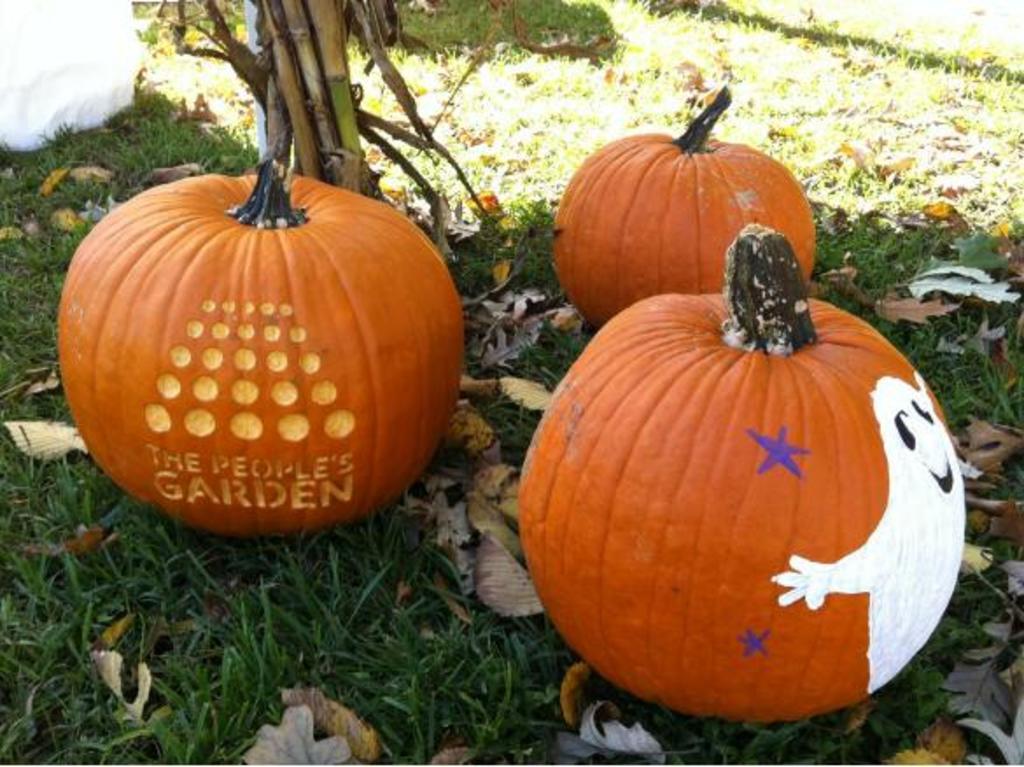Describe this image in one or two sentences. There are pumpkins kept on a grassy land as we can see in the middle of this image. We can see stems at the top of this image. 